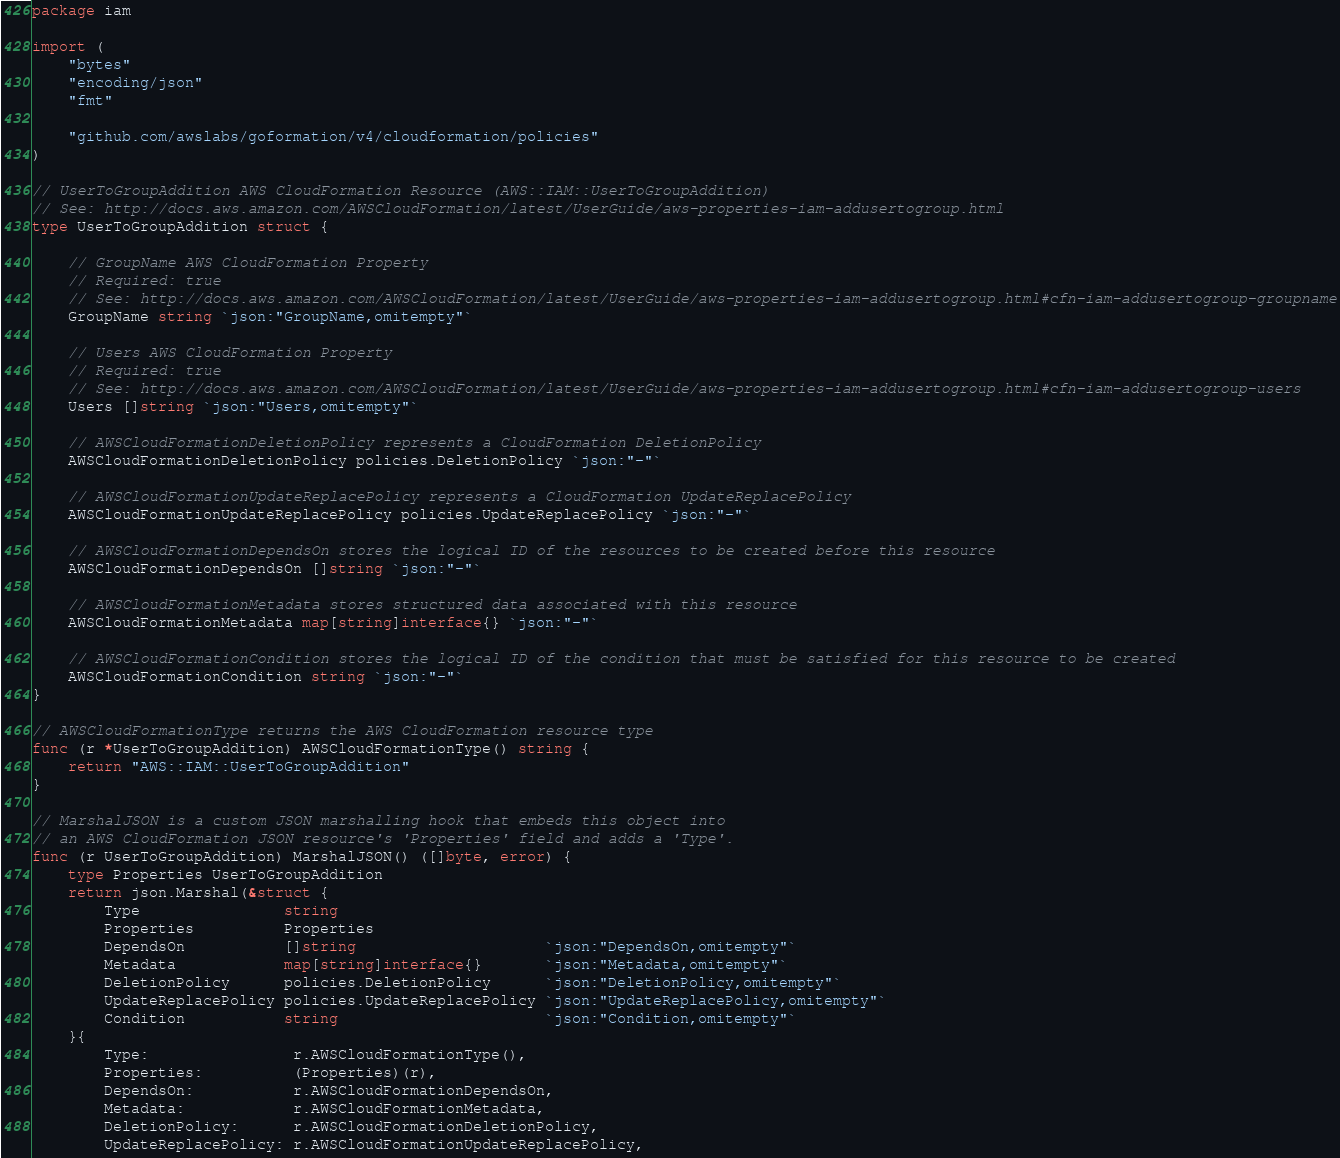<code> <loc_0><loc_0><loc_500><loc_500><_Go_>package iam

import (
	"bytes"
	"encoding/json"
	"fmt"

	"github.com/awslabs/goformation/v4/cloudformation/policies"
)

// UserToGroupAddition AWS CloudFormation Resource (AWS::IAM::UserToGroupAddition)
// See: http://docs.aws.amazon.com/AWSCloudFormation/latest/UserGuide/aws-properties-iam-addusertogroup.html
type UserToGroupAddition struct {

	// GroupName AWS CloudFormation Property
	// Required: true
	// See: http://docs.aws.amazon.com/AWSCloudFormation/latest/UserGuide/aws-properties-iam-addusertogroup.html#cfn-iam-addusertogroup-groupname
	GroupName string `json:"GroupName,omitempty"`

	// Users AWS CloudFormation Property
	// Required: true
	// See: http://docs.aws.amazon.com/AWSCloudFormation/latest/UserGuide/aws-properties-iam-addusertogroup.html#cfn-iam-addusertogroup-users
	Users []string `json:"Users,omitempty"`

	// AWSCloudFormationDeletionPolicy represents a CloudFormation DeletionPolicy
	AWSCloudFormationDeletionPolicy policies.DeletionPolicy `json:"-"`

	// AWSCloudFormationUpdateReplacePolicy represents a CloudFormation UpdateReplacePolicy
	AWSCloudFormationUpdateReplacePolicy policies.UpdateReplacePolicy `json:"-"`

	// AWSCloudFormationDependsOn stores the logical ID of the resources to be created before this resource
	AWSCloudFormationDependsOn []string `json:"-"`

	// AWSCloudFormationMetadata stores structured data associated with this resource
	AWSCloudFormationMetadata map[string]interface{} `json:"-"`

	// AWSCloudFormationCondition stores the logical ID of the condition that must be satisfied for this resource to be created
	AWSCloudFormationCondition string `json:"-"`
}

// AWSCloudFormationType returns the AWS CloudFormation resource type
func (r *UserToGroupAddition) AWSCloudFormationType() string {
	return "AWS::IAM::UserToGroupAddition"
}

// MarshalJSON is a custom JSON marshalling hook that embeds this object into
// an AWS CloudFormation JSON resource's 'Properties' field and adds a 'Type'.
func (r UserToGroupAddition) MarshalJSON() ([]byte, error) {
	type Properties UserToGroupAddition
	return json.Marshal(&struct {
		Type                string
		Properties          Properties
		DependsOn           []string                     `json:"DependsOn,omitempty"`
		Metadata            map[string]interface{}       `json:"Metadata,omitempty"`
		DeletionPolicy      policies.DeletionPolicy      `json:"DeletionPolicy,omitempty"`
		UpdateReplacePolicy policies.UpdateReplacePolicy `json:"UpdateReplacePolicy,omitempty"`
		Condition           string                       `json:"Condition,omitempty"`
	}{
		Type:                r.AWSCloudFormationType(),
		Properties:          (Properties)(r),
		DependsOn:           r.AWSCloudFormationDependsOn,
		Metadata:            r.AWSCloudFormationMetadata,
		DeletionPolicy:      r.AWSCloudFormationDeletionPolicy,
		UpdateReplacePolicy: r.AWSCloudFormationUpdateReplacePolicy,</code> 